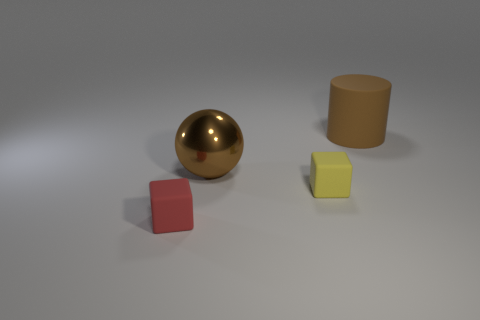Is there anything else that is the same material as the sphere?
Your response must be concise. No. What is the material of the large brown ball left of the small matte cube to the right of the small red block?
Your response must be concise. Metal. Do the brown matte cylinder and the red object have the same size?
Offer a terse response. No. How many objects are big blue metallic spheres or tiny things?
Offer a very short reply. 2. There is a thing that is behind the yellow matte block and left of the yellow thing; what size is it?
Keep it short and to the point. Large. Is the number of large brown rubber objects to the left of the yellow rubber cube less than the number of small brown metallic cylinders?
Ensure brevity in your answer.  No. There is a small object that is the same material as the red block; what shape is it?
Your response must be concise. Cube. There is a small object that is on the right side of the metallic ball; is its shape the same as the object left of the shiny ball?
Ensure brevity in your answer.  Yes. Is the number of large metallic objects behind the big brown sphere less than the number of tiny objects that are to the left of the tiny yellow rubber object?
Your answer should be very brief. Yes. There is a big matte thing that is the same color as the large metallic ball; what is its shape?
Your answer should be compact. Cylinder. 